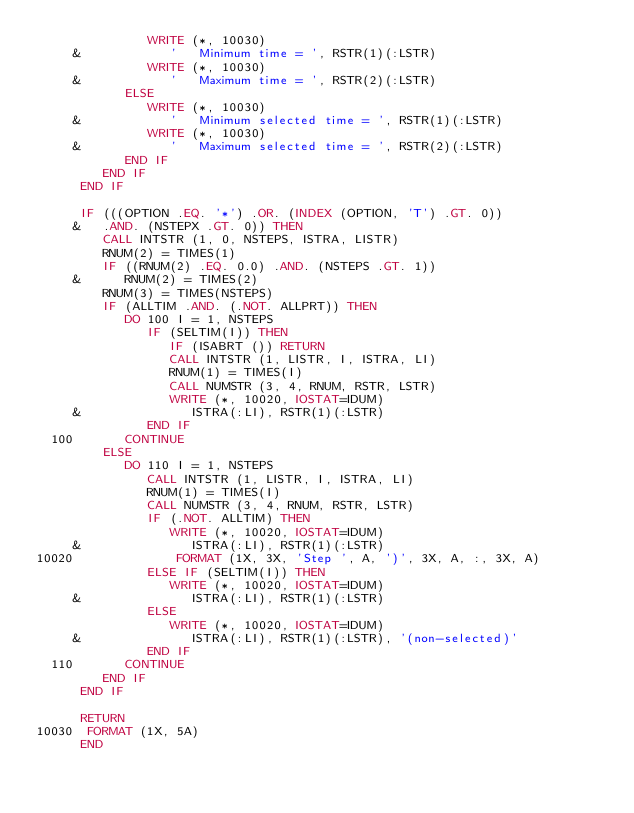Convert code to text. <code><loc_0><loc_0><loc_500><loc_500><_FORTRAN_>               WRITE (*, 10030)
     &            '   Minimum time = ', RSTR(1)(:LSTR)
               WRITE (*, 10030)
     &            '   Maximum time = ', RSTR(2)(:LSTR)
            ELSE
               WRITE (*, 10030)
     &            '   Minimum selected time = ', RSTR(1)(:LSTR)
               WRITE (*, 10030)
     &            '   Maximum selected time = ', RSTR(2)(:LSTR)
            END IF
         END IF
      END IF

      IF (((OPTION .EQ. '*') .OR. (INDEX (OPTION, 'T') .GT. 0))
     &   .AND. (NSTEPX .GT. 0)) THEN
         CALL INTSTR (1, 0, NSTEPS, ISTRA, LISTR)
         RNUM(2) = TIMES(1)
         IF ((RNUM(2) .EQ. 0.0) .AND. (NSTEPS .GT. 1))
     &      RNUM(2) = TIMES(2)
         RNUM(3) = TIMES(NSTEPS)
         IF (ALLTIM .AND. (.NOT. ALLPRT)) THEN
            DO 100 I = 1, NSTEPS
               IF (SELTIM(I)) THEN
                  IF (ISABRT ()) RETURN
                  CALL INTSTR (1, LISTR, I, ISTRA, LI)
                  RNUM(1) = TIMES(I)
                  CALL NUMSTR (3, 4, RNUM, RSTR, LSTR)
                  WRITE (*, 10020, IOSTAT=IDUM)
     &               ISTRA(:LI), RSTR(1)(:LSTR)
               END IF
  100       CONTINUE
         ELSE
            DO 110 I = 1, NSTEPS
               CALL INTSTR (1, LISTR, I, ISTRA, LI)
               RNUM(1) = TIMES(I)
               CALL NUMSTR (3, 4, RNUM, RSTR, LSTR)
               IF (.NOT. ALLTIM) THEN
                  WRITE (*, 10020, IOSTAT=IDUM)
     &               ISTRA(:LI), RSTR(1)(:LSTR)
10020              FORMAT (1X, 3X, 'Step ', A, ')', 3X, A, :, 3X, A)
               ELSE IF (SELTIM(I)) THEN
                  WRITE (*, 10020, IOSTAT=IDUM)
     &               ISTRA(:LI), RSTR(1)(:LSTR)
               ELSE
                  WRITE (*, 10020, IOSTAT=IDUM)
     &               ISTRA(:LI), RSTR(1)(:LSTR), '(non-selected)'
               END IF
  110       CONTINUE
         END IF
      END IF

      RETURN
10030  FORMAT (1X, 5A)
      END
</code> 